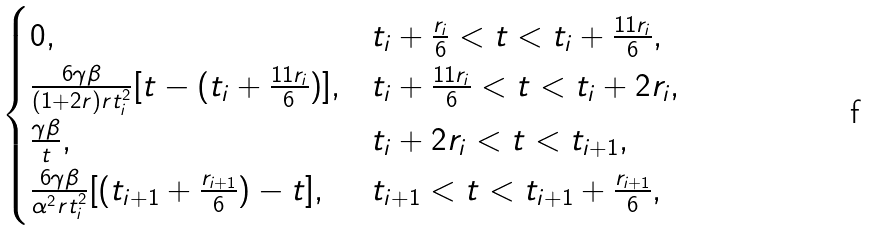Convert formula to latex. <formula><loc_0><loc_0><loc_500><loc_500>\begin{cases} 0 , & t _ { i } + \frac { r _ { i } } { 6 } < t < t _ { i } + \frac { 1 1 r _ { i } } { 6 } , \\ \frac { 6 \gamma \beta } { ( 1 + 2 r ) r t _ { i } ^ { 2 } } [ t - ( t _ { i } + \frac { 1 1 r _ { i } } { 6 } ) ] , & t _ { i } + \frac { 1 1 r _ { i } } { 6 } < t < t _ { i } + 2 r _ { i } , \\ \frac { \gamma \beta } { t } , & t _ { i } + 2 r _ { i } < t < t _ { i + 1 } , \\ \frac { 6 \gamma \beta } { \alpha ^ { 2 } r t _ { i } ^ { 2 } } [ ( t _ { i + 1 } + \frac { r _ { i + 1 } } { 6 } ) - t ] , & t _ { i + 1 } < t < t _ { i + 1 } + \frac { r _ { i + 1 } } { 6 } , \end{cases}</formula> 